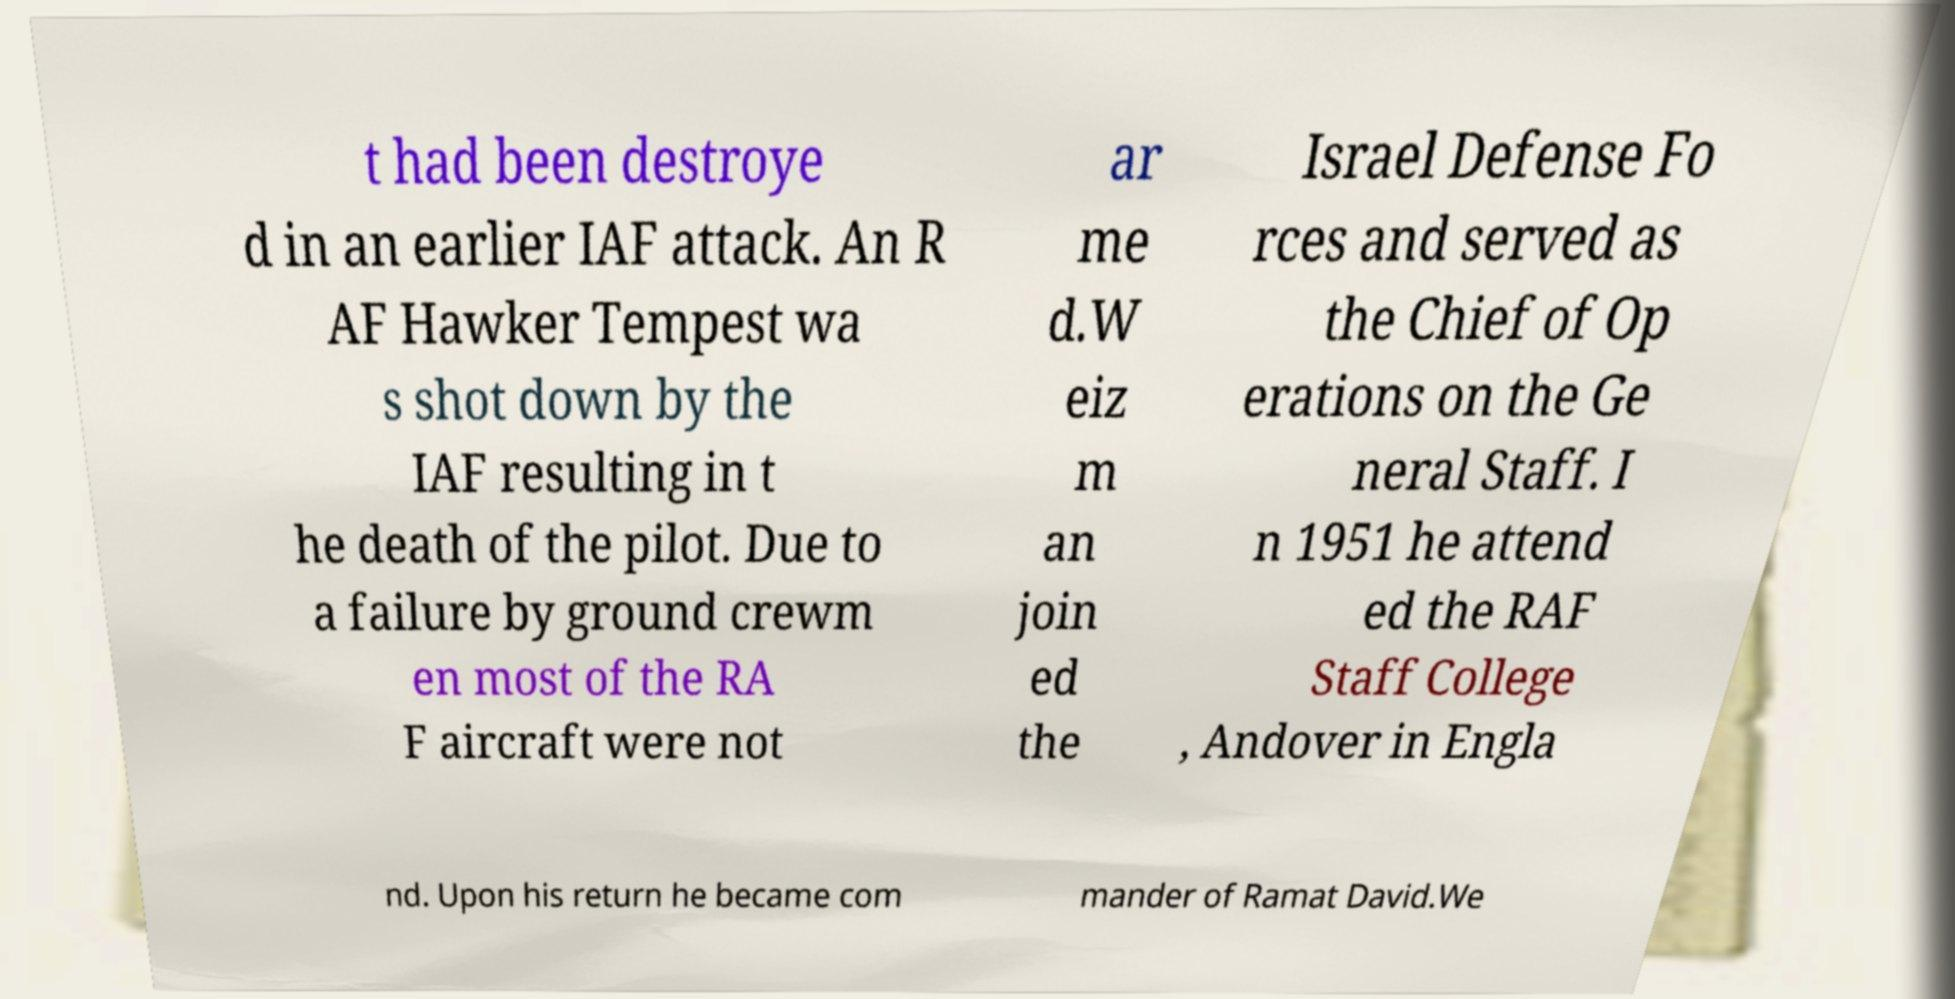Can you read and provide the text displayed in the image?This photo seems to have some interesting text. Can you extract and type it out for me? t had been destroye d in an earlier IAF attack. An R AF Hawker Tempest wa s shot down by the IAF resulting in t he death of the pilot. Due to a failure by ground crewm en most of the RA F aircraft were not ar me d.W eiz m an join ed the Israel Defense Fo rces and served as the Chief of Op erations on the Ge neral Staff. I n 1951 he attend ed the RAF Staff College , Andover in Engla nd. Upon his return he became com mander of Ramat David.We 